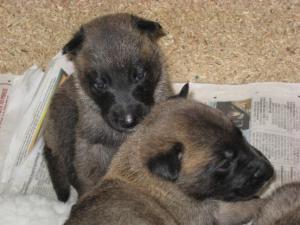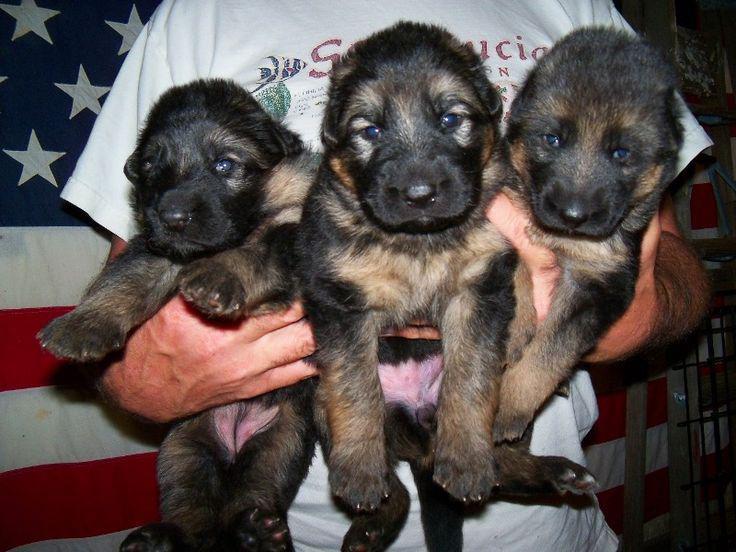The first image is the image on the left, the second image is the image on the right. For the images displayed, is the sentence "A person is holding at least one of the dogs in one of the images." factually correct? Answer yes or no. Yes. The first image is the image on the left, the second image is the image on the right. Given the left and right images, does the statement "A person is holding at least one dog in one image." hold true? Answer yes or no. Yes. 